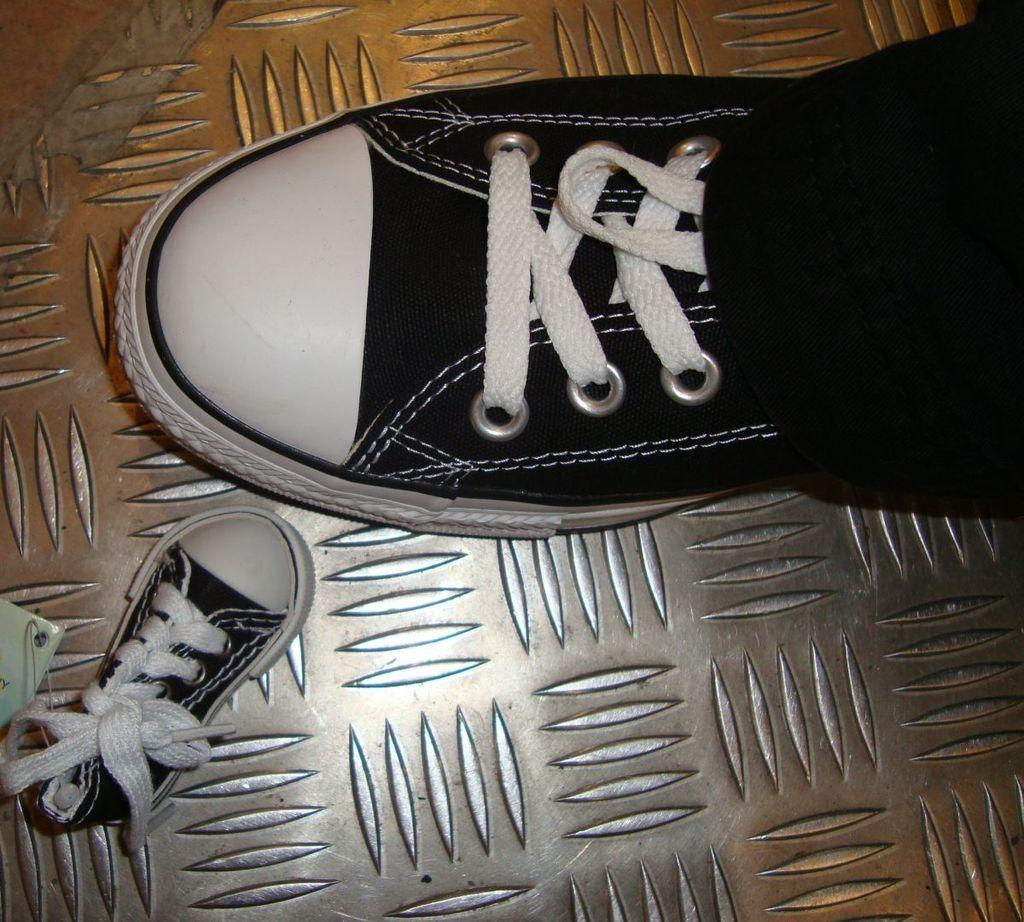What is the person in the image wearing on their foot? The person is wearing a shoe in the image. Can you describe the shoe's size? The shoe is big in size. What colors are present on the shoe? The shoe is white and black in color. Are there any other shoes visible in the image? Yes, there is a small size shoe in the image. What is the color of the small size shoe? The small size shoe is also white and black in color. What type of unit is being taught in the class shown in the image? There is no class or unit present in the image; it only features a person wearing a shoe and another shoe. 